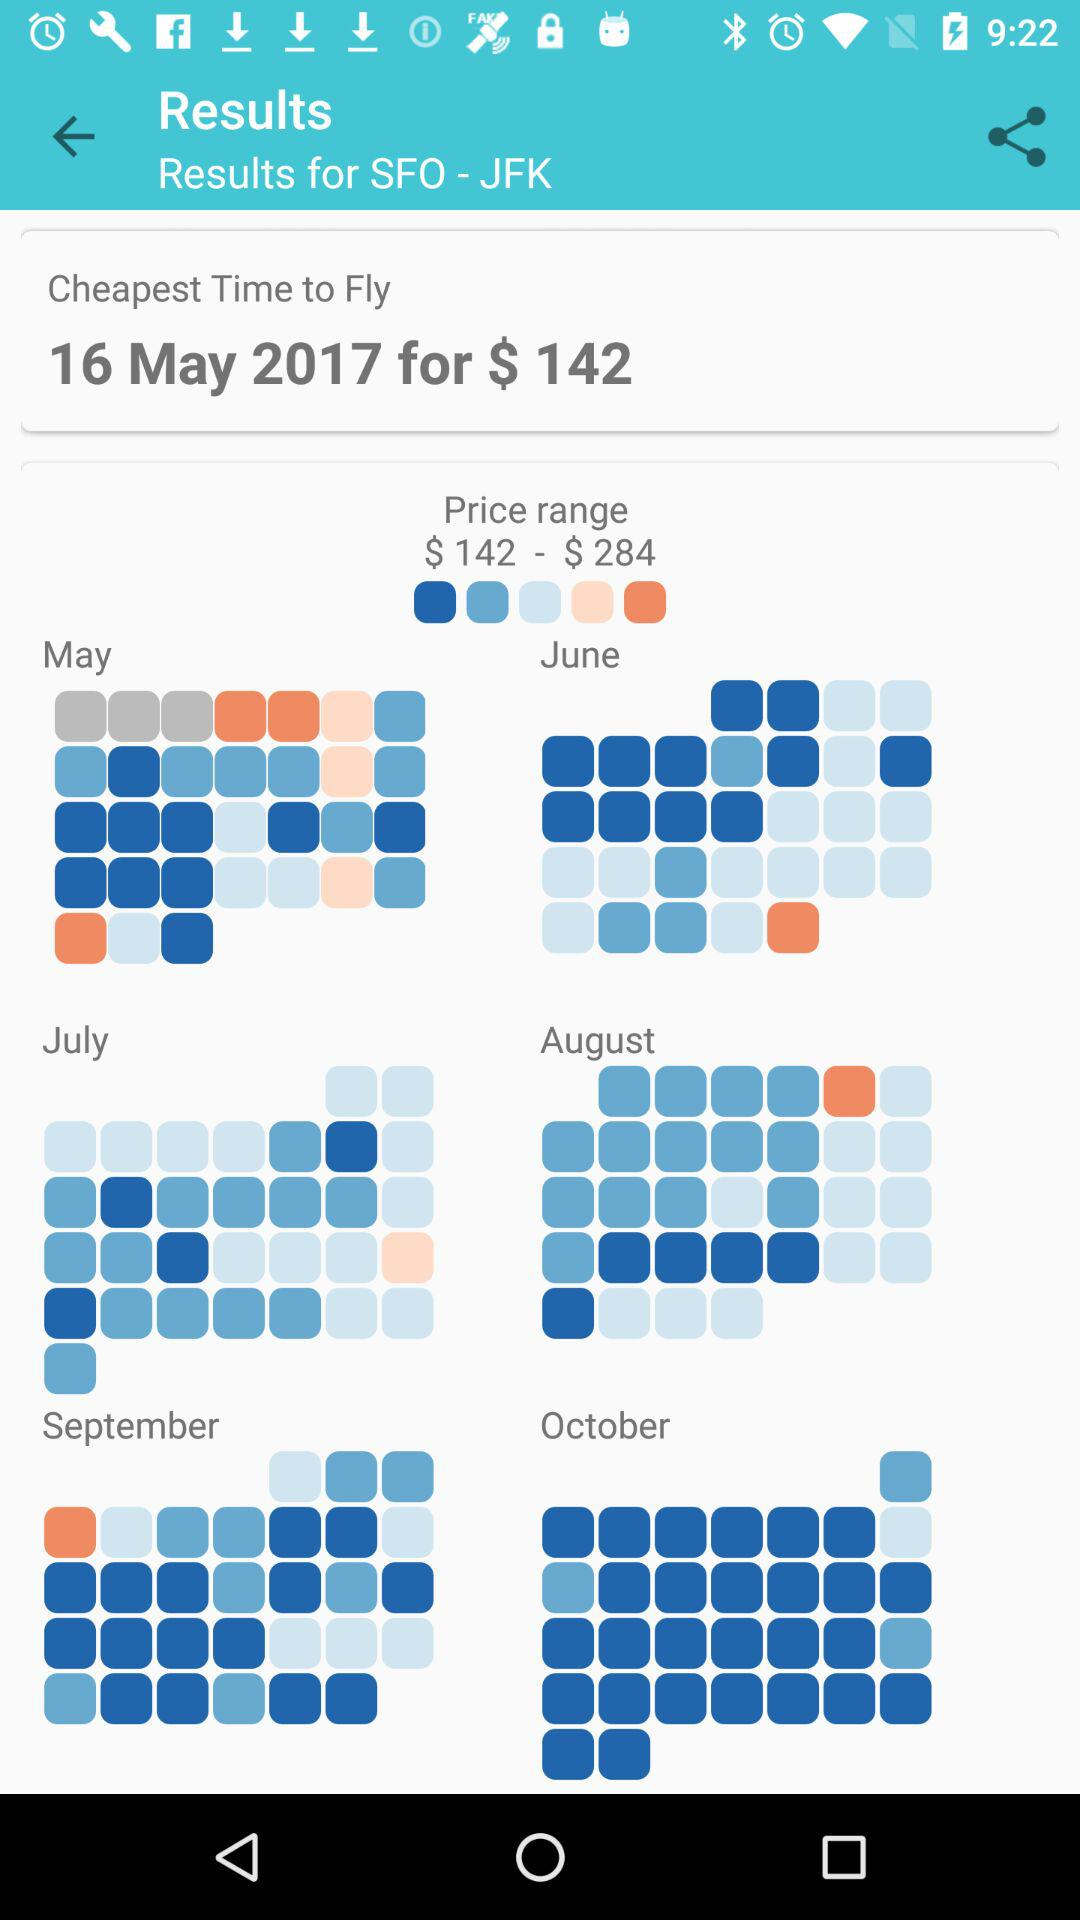What is the given price range? The given price range is from $142 to $284. 